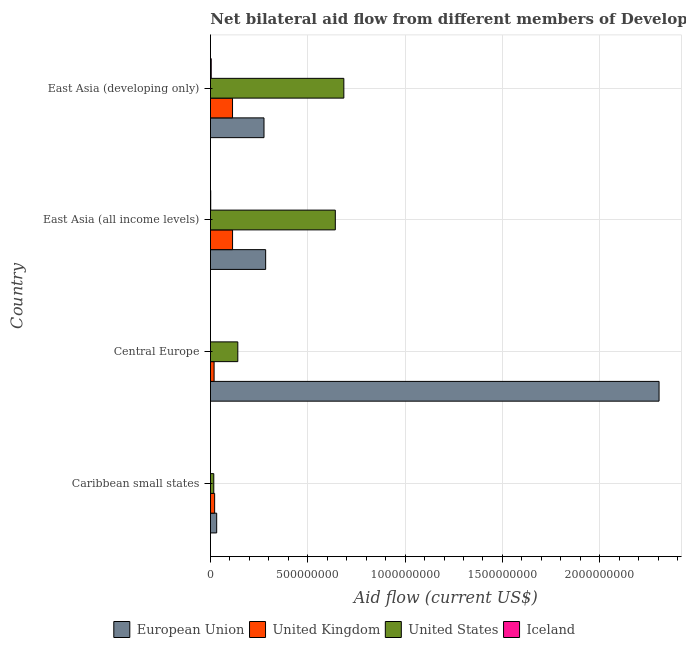How many bars are there on the 3rd tick from the bottom?
Your answer should be very brief. 4. What is the label of the 4th group of bars from the top?
Ensure brevity in your answer.  Caribbean small states. What is the amount of aid given by eu in Caribbean small states?
Your response must be concise. 3.19e+07. Across all countries, what is the maximum amount of aid given by iceland?
Offer a terse response. 3.94e+06. Across all countries, what is the minimum amount of aid given by uk?
Make the answer very short. 1.86e+07. In which country was the amount of aid given by uk maximum?
Keep it short and to the point. East Asia (all income levels). In which country was the amount of aid given by iceland minimum?
Give a very brief answer. Caribbean small states. What is the total amount of aid given by eu in the graph?
Ensure brevity in your answer.  2.90e+09. What is the difference between the amount of aid given by us in East Asia (all income levels) and that in East Asia (developing only)?
Offer a very short reply. -4.38e+07. What is the difference between the amount of aid given by eu in East Asia (all income levels) and the amount of aid given by uk in East Asia (developing only)?
Your response must be concise. 1.70e+08. What is the average amount of aid given by iceland per country?
Offer a terse response. 1.33e+06. What is the difference between the amount of aid given by uk and amount of aid given by eu in Caribbean small states?
Your answer should be very brief. -1.05e+07. What is the ratio of the amount of aid given by iceland in Central Europe to that in East Asia (developing only)?
Make the answer very short. 0.01. Is the amount of aid given by iceland in Caribbean small states less than that in East Asia (all income levels)?
Provide a short and direct response. Yes. What is the difference between the highest and the second highest amount of aid given by iceland?
Keep it short and to the point. 2.69e+06. What is the difference between the highest and the lowest amount of aid given by iceland?
Offer a terse response. 3.88e+06. In how many countries, is the amount of aid given by eu greater than the average amount of aid given by eu taken over all countries?
Provide a succinct answer. 1. What does the 4th bar from the bottom in Central Europe represents?
Provide a succinct answer. Iceland. How many countries are there in the graph?
Offer a very short reply. 4. What is the difference between two consecutive major ticks on the X-axis?
Offer a very short reply. 5.00e+08. Does the graph contain any zero values?
Provide a succinct answer. No. Where does the legend appear in the graph?
Provide a succinct answer. Bottom center. What is the title of the graph?
Provide a succinct answer. Net bilateral aid flow from different members of Development Assistance Committee in the year 2003. Does "Gender equality" appear as one of the legend labels in the graph?
Offer a terse response. No. What is the label or title of the Y-axis?
Offer a terse response. Country. What is the Aid flow (current US$) in European Union in Caribbean small states?
Keep it short and to the point. 3.19e+07. What is the Aid flow (current US$) in United Kingdom in Caribbean small states?
Provide a succinct answer. 2.14e+07. What is the Aid flow (current US$) in United States in Caribbean small states?
Your answer should be compact. 1.70e+07. What is the Aid flow (current US$) of Iceland in Caribbean small states?
Your answer should be very brief. 6.00e+04. What is the Aid flow (current US$) in European Union in Central Europe?
Your response must be concise. 2.30e+09. What is the Aid flow (current US$) in United Kingdom in Central Europe?
Provide a short and direct response. 1.86e+07. What is the Aid flow (current US$) in United States in Central Europe?
Offer a terse response. 1.40e+08. What is the Aid flow (current US$) of Iceland in Central Europe?
Give a very brief answer. 6.00e+04. What is the Aid flow (current US$) of European Union in East Asia (all income levels)?
Provide a succinct answer. 2.84e+08. What is the Aid flow (current US$) in United Kingdom in East Asia (all income levels)?
Your response must be concise. 1.13e+08. What is the Aid flow (current US$) in United States in East Asia (all income levels)?
Ensure brevity in your answer.  6.41e+08. What is the Aid flow (current US$) in Iceland in East Asia (all income levels)?
Your answer should be very brief. 1.25e+06. What is the Aid flow (current US$) in European Union in East Asia (developing only)?
Ensure brevity in your answer.  2.75e+08. What is the Aid flow (current US$) in United Kingdom in East Asia (developing only)?
Offer a terse response. 1.13e+08. What is the Aid flow (current US$) in United States in East Asia (developing only)?
Offer a terse response. 6.85e+08. What is the Aid flow (current US$) of Iceland in East Asia (developing only)?
Make the answer very short. 3.94e+06. Across all countries, what is the maximum Aid flow (current US$) of European Union?
Make the answer very short. 2.30e+09. Across all countries, what is the maximum Aid flow (current US$) in United Kingdom?
Your answer should be compact. 1.13e+08. Across all countries, what is the maximum Aid flow (current US$) of United States?
Provide a short and direct response. 6.85e+08. Across all countries, what is the maximum Aid flow (current US$) in Iceland?
Give a very brief answer. 3.94e+06. Across all countries, what is the minimum Aid flow (current US$) in European Union?
Make the answer very short. 3.19e+07. Across all countries, what is the minimum Aid flow (current US$) of United Kingdom?
Your answer should be compact. 1.86e+07. Across all countries, what is the minimum Aid flow (current US$) of United States?
Provide a short and direct response. 1.70e+07. Across all countries, what is the minimum Aid flow (current US$) of Iceland?
Offer a terse response. 6.00e+04. What is the total Aid flow (current US$) of European Union in the graph?
Provide a short and direct response. 2.90e+09. What is the total Aid flow (current US$) in United Kingdom in the graph?
Make the answer very short. 2.67e+08. What is the total Aid flow (current US$) of United States in the graph?
Give a very brief answer. 1.48e+09. What is the total Aid flow (current US$) of Iceland in the graph?
Your response must be concise. 5.31e+06. What is the difference between the Aid flow (current US$) in European Union in Caribbean small states and that in Central Europe?
Your answer should be compact. -2.27e+09. What is the difference between the Aid flow (current US$) of United Kingdom in Caribbean small states and that in Central Europe?
Keep it short and to the point. 2.83e+06. What is the difference between the Aid flow (current US$) in United States in Caribbean small states and that in Central Europe?
Ensure brevity in your answer.  -1.24e+08. What is the difference between the Aid flow (current US$) in European Union in Caribbean small states and that in East Asia (all income levels)?
Your response must be concise. -2.52e+08. What is the difference between the Aid flow (current US$) in United Kingdom in Caribbean small states and that in East Asia (all income levels)?
Provide a short and direct response. -9.20e+07. What is the difference between the Aid flow (current US$) in United States in Caribbean small states and that in East Asia (all income levels)?
Your response must be concise. -6.24e+08. What is the difference between the Aid flow (current US$) in Iceland in Caribbean small states and that in East Asia (all income levels)?
Your answer should be compact. -1.19e+06. What is the difference between the Aid flow (current US$) in European Union in Caribbean small states and that in East Asia (developing only)?
Provide a succinct answer. -2.43e+08. What is the difference between the Aid flow (current US$) of United Kingdom in Caribbean small states and that in East Asia (developing only)?
Your answer should be very brief. -9.19e+07. What is the difference between the Aid flow (current US$) in United States in Caribbean small states and that in East Asia (developing only)?
Provide a succinct answer. -6.68e+08. What is the difference between the Aid flow (current US$) of Iceland in Caribbean small states and that in East Asia (developing only)?
Offer a terse response. -3.88e+06. What is the difference between the Aid flow (current US$) in European Union in Central Europe and that in East Asia (all income levels)?
Provide a succinct answer. 2.02e+09. What is the difference between the Aid flow (current US$) of United Kingdom in Central Europe and that in East Asia (all income levels)?
Your answer should be compact. -9.49e+07. What is the difference between the Aid flow (current US$) of United States in Central Europe and that in East Asia (all income levels)?
Offer a terse response. -5.01e+08. What is the difference between the Aid flow (current US$) of Iceland in Central Europe and that in East Asia (all income levels)?
Offer a terse response. -1.19e+06. What is the difference between the Aid flow (current US$) of European Union in Central Europe and that in East Asia (developing only)?
Offer a very short reply. 2.03e+09. What is the difference between the Aid flow (current US$) of United Kingdom in Central Europe and that in East Asia (developing only)?
Offer a terse response. -9.47e+07. What is the difference between the Aid flow (current US$) in United States in Central Europe and that in East Asia (developing only)?
Offer a very short reply. -5.45e+08. What is the difference between the Aid flow (current US$) of Iceland in Central Europe and that in East Asia (developing only)?
Give a very brief answer. -3.88e+06. What is the difference between the Aid flow (current US$) in European Union in East Asia (all income levels) and that in East Asia (developing only)?
Make the answer very short. 8.50e+06. What is the difference between the Aid flow (current US$) of United Kingdom in East Asia (all income levels) and that in East Asia (developing only)?
Give a very brief answer. 1.50e+05. What is the difference between the Aid flow (current US$) in United States in East Asia (all income levels) and that in East Asia (developing only)?
Your response must be concise. -4.38e+07. What is the difference between the Aid flow (current US$) in Iceland in East Asia (all income levels) and that in East Asia (developing only)?
Provide a succinct answer. -2.69e+06. What is the difference between the Aid flow (current US$) in European Union in Caribbean small states and the Aid flow (current US$) in United Kingdom in Central Europe?
Your answer should be very brief. 1.33e+07. What is the difference between the Aid flow (current US$) in European Union in Caribbean small states and the Aid flow (current US$) in United States in Central Europe?
Ensure brevity in your answer.  -1.09e+08. What is the difference between the Aid flow (current US$) of European Union in Caribbean small states and the Aid flow (current US$) of Iceland in Central Europe?
Offer a very short reply. 3.19e+07. What is the difference between the Aid flow (current US$) in United Kingdom in Caribbean small states and the Aid flow (current US$) in United States in Central Europe?
Give a very brief answer. -1.19e+08. What is the difference between the Aid flow (current US$) in United Kingdom in Caribbean small states and the Aid flow (current US$) in Iceland in Central Europe?
Your answer should be compact. 2.14e+07. What is the difference between the Aid flow (current US$) in United States in Caribbean small states and the Aid flow (current US$) in Iceland in Central Europe?
Offer a terse response. 1.69e+07. What is the difference between the Aid flow (current US$) of European Union in Caribbean small states and the Aid flow (current US$) of United Kingdom in East Asia (all income levels)?
Provide a short and direct response. -8.16e+07. What is the difference between the Aid flow (current US$) in European Union in Caribbean small states and the Aid flow (current US$) in United States in East Asia (all income levels)?
Provide a succinct answer. -6.10e+08. What is the difference between the Aid flow (current US$) of European Union in Caribbean small states and the Aid flow (current US$) of Iceland in East Asia (all income levels)?
Provide a succinct answer. 3.07e+07. What is the difference between the Aid flow (current US$) of United Kingdom in Caribbean small states and the Aid flow (current US$) of United States in East Asia (all income levels)?
Ensure brevity in your answer.  -6.20e+08. What is the difference between the Aid flow (current US$) in United Kingdom in Caribbean small states and the Aid flow (current US$) in Iceland in East Asia (all income levels)?
Keep it short and to the point. 2.02e+07. What is the difference between the Aid flow (current US$) in United States in Caribbean small states and the Aid flow (current US$) in Iceland in East Asia (all income levels)?
Your response must be concise. 1.57e+07. What is the difference between the Aid flow (current US$) of European Union in Caribbean small states and the Aid flow (current US$) of United Kingdom in East Asia (developing only)?
Provide a succinct answer. -8.14e+07. What is the difference between the Aid flow (current US$) in European Union in Caribbean small states and the Aid flow (current US$) in United States in East Asia (developing only)?
Provide a short and direct response. -6.53e+08. What is the difference between the Aid flow (current US$) of European Union in Caribbean small states and the Aid flow (current US$) of Iceland in East Asia (developing only)?
Offer a very short reply. 2.80e+07. What is the difference between the Aid flow (current US$) in United Kingdom in Caribbean small states and the Aid flow (current US$) in United States in East Asia (developing only)?
Your answer should be compact. -6.64e+08. What is the difference between the Aid flow (current US$) in United Kingdom in Caribbean small states and the Aid flow (current US$) in Iceland in East Asia (developing only)?
Offer a very short reply. 1.75e+07. What is the difference between the Aid flow (current US$) of United States in Caribbean small states and the Aid flow (current US$) of Iceland in East Asia (developing only)?
Ensure brevity in your answer.  1.30e+07. What is the difference between the Aid flow (current US$) in European Union in Central Europe and the Aid flow (current US$) in United Kingdom in East Asia (all income levels)?
Your answer should be very brief. 2.19e+09. What is the difference between the Aid flow (current US$) in European Union in Central Europe and the Aid flow (current US$) in United States in East Asia (all income levels)?
Keep it short and to the point. 1.66e+09. What is the difference between the Aid flow (current US$) of European Union in Central Europe and the Aid flow (current US$) of Iceland in East Asia (all income levels)?
Make the answer very short. 2.30e+09. What is the difference between the Aid flow (current US$) in United Kingdom in Central Europe and the Aid flow (current US$) in United States in East Asia (all income levels)?
Your answer should be compact. -6.23e+08. What is the difference between the Aid flow (current US$) of United Kingdom in Central Europe and the Aid flow (current US$) of Iceland in East Asia (all income levels)?
Keep it short and to the point. 1.74e+07. What is the difference between the Aid flow (current US$) of United States in Central Europe and the Aid flow (current US$) of Iceland in East Asia (all income levels)?
Your answer should be compact. 1.39e+08. What is the difference between the Aid flow (current US$) in European Union in Central Europe and the Aid flow (current US$) in United Kingdom in East Asia (developing only)?
Offer a terse response. 2.19e+09. What is the difference between the Aid flow (current US$) in European Union in Central Europe and the Aid flow (current US$) in United States in East Asia (developing only)?
Make the answer very short. 1.62e+09. What is the difference between the Aid flow (current US$) of European Union in Central Europe and the Aid flow (current US$) of Iceland in East Asia (developing only)?
Your answer should be compact. 2.30e+09. What is the difference between the Aid flow (current US$) in United Kingdom in Central Europe and the Aid flow (current US$) in United States in East Asia (developing only)?
Your answer should be compact. -6.67e+08. What is the difference between the Aid flow (current US$) of United Kingdom in Central Europe and the Aid flow (current US$) of Iceland in East Asia (developing only)?
Your response must be concise. 1.47e+07. What is the difference between the Aid flow (current US$) in United States in Central Europe and the Aid flow (current US$) in Iceland in East Asia (developing only)?
Provide a short and direct response. 1.37e+08. What is the difference between the Aid flow (current US$) in European Union in East Asia (all income levels) and the Aid flow (current US$) in United Kingdom in East Asia (developing only)?
Your answer should be very brief. 1.70e+08. What is the difference between the Aid flow (current US$) of European Union in East Asia (all income levels) and the Aid flow (current US$) of United States in East Asia (developing only)?
Offer a terse response. -4.02e+08. What is the difference between the Aid flow (current US$) in European Union in East Asia (all income levels) and the Aid flow (current US$) in Iceland in East Asia (developing only)?
Keep it short and to the point. 2.80e+08. What is the difference between the Aid flow (current US$) of United Kingdom in East Asia (all income levels) and the Aid flow (current US$) of United States in East Asia (developing only)?
Give a very brief answer. -5.72e+08. What is the difference between the Aid flow (current US$) in United Kingdom in East Asia (all income levels) and the Aid flow (current US$) in Iceland in East Asia (developing only)?
Your answer should be compact. 1.10e+08. What is the difference between the Aid flow (current US$) in United States in East Asia (all income levels) and the Aid flow (current US$) in Iceland in East Asia (developing only)?
Offer a very short reply. 6.38e+08. What is the average Aid flow (current US$) in European Union per country?
Make the answer very short. 7.24e+08. What is the average Aid flow (current US$) of United Kingdom per country?
Provide a short and direct response. 6.67e+07. What is the average Aid flow (current US$) in United States per country?
Your response must be concise. 3.71e+08. What is the average Aid flow (current US$) in Iceland per country?
Your response must be concise. 1.33e+06. What is the difference between the Aid flow (current US$) of European Union and Aid flow (current US$) of United Kingdom in Caribbean small states?
Offer a terse response. 1.05e+07. What is the difference between the Aid flow (current US$) in European Union and Aid flow (current US$) in United States in Caribbean small states?
Ensure brevity in your answer.  1.49e+07. What is the difference between the Aid flow (current US$) of European Union and Aid flow (current US$) of Iceland in Caribbean small states?
Keep it short and to the point. 3.19e+07. What is the difference between the Aid flow (current US$) of United Kingdom and Aid flow (current US$) of United States in Caribbean small states?
Offer a terse response. 4.47e+06. What is the difference between the Aid flow (current US$) of United Kingdom and Aid flow (current US$) of Iceland in Caribbean small states?
Your answer should be compact. 2.14e+07. What is the difference between the Aid flow (current US$) in United States and Aid flow (current US$) in Iceland in Caribbean small states?
Offer a very short reply. 1.69e+07. What is the difference between the Aid flow (current US$) in European Union and Aid flow (current US$) in United Kingdom in Central Europe?
Make the answer very short. 2.29e+09. What is the difference between the Aid flow (current US$) in European Union and Aid flow (current US$) in United States in Central Europe?
Offer a very short reply. 2.16e+09. What is the difference between the Aid flow (current US$) of European Union and Aid flow (current US$) of Iceland in Central Europe?
Your answer should be compact. 2.30e+09. What is the difference between the Aid flow (current US$) in United Kingdom and Aid flow (current US$) in United States in Central Europe?
Give a very brief answer. -1.22e+08. What is the difference between the Aid flow (current US$) of United Kingdom and Aid flow (current US$) of Iceland in Central Europe?
Your answer should be very brief. 1.86e+07. What is the difference between the Aid flow (current US$) in United States and Aid flow (current US$) in Iceland in Central Europe?
Offer a very short reply. 1.40e+08. What is the difference between the Aid flow (current US$) in European Union and Aid flow (current US$) in United Kingdom in East Asia (all income levels)?
Offer a very short reply. 1.70e+08. What is the difference between the Aid flow (current US$) in European Union and Aid flow (current US$) in United States in East Asia (all income levels)?
Your answer should be compact. -3.58e+08. What is the difference between the Aid flow (current US$) of European Union and Aid flow (current US$) of Iceland in East Asia (all income levels)?
Ensure brevity in your answer.  2.82e+08. What is the difference between the Aid flow (current US$) in United Kingdom and Aid flow (current US$) in United States in East Asia (all income levels)?
Ensure brevity in your answer.  -5.28e+08. What is the difference between the Aid flow (current US$) in United Kingdom and Aid flow (current US$) in Iceland in East Asia (all income levels)?
Your answer should be very brief. 1.12e+08. What is the difference between the Aid flow (current US$) of United States and Aid flow (current US$) of Iceland in East Asia (all income levels)?
Your answer should be very brief. 6.40e+08. What is the difference between the Aid flow (current US$) of European Union and Aid flow (current US$) of United Kingdom in East Asia (developing only)?
Provide a short and direct response. 1.62e+08. What is the difference between the Aid flow (current US$) in European Union and Aid flow (current US$) in United States in East Asia (developing only)?
Your answer should be very brief. -4.10e+08. What is the difference between the Aid flow (current US$) in European Union and Aid flow (current US$) in Iceland in East Asia (developing only)?
Your answer should be compact. 2.71e+08. What is the difference between the Aid flow (current US$) of United Kingdom and Aid flow (current US$) of United States in East Asia (developing only)?
Provide a short and direct response. -5.72e+08. What is the difference between the Aid flow (current US$) in United Kingdom and Aid flow (current US$) in Iceland in East Asia (developing only)?
Provide a short and direct response. 1.09e+08. What is the difference between the Aid flow (current US$) in United States and Aid flow (current US$) in Iceland in East Asia (developing only)?
Offer a very short reply. 6.81e+08. What is the ratio of the Aid flow (current US$) of European Union in Caribbean small states to that in Central Europe?
Give a very brief answer. 0.01. What is the ratio of the Aid flow (current US$) in United Kingdom in Caribbean small states to that in Central Europe?
Provide a short and direct response. 1.15. What is the ratio of the Aid flow (current US$) in United States in Caribbean small states to that in Central Europe?
Make the answer very short. 0.12. What is the ratio of the Aid flow (current US$) in Iceland in Caribbean small states to that in Central Europe?
Ensure brevity in your answer.  1. What is the ratio of the Aid flow (current US$) of European Union in Caribbean small states to that in East Asia (all income levels)?
Ensure brevity in your answer.  0.11. What is the ratio of the Aid flow (current US$) in United Kingdom in Caribbean small states to that in East Asia (all income levels)?
Give a very brief answer. 0.19. What is the ratio of the Aid flow (current US$) of United States in Caribbean small states to that in East Asia (all income levels)?
Ensure brevity in your answer.  0.03. What is the ratio of the Aid flow (current US$) of Iceland in Caribbean small states to that in East Asia (all income levels)?
Keep it short and to the point. 0.05. What is the ratio of the Aid flow (current US$) in European Union in Caribbean small states to that in East Asia (developing only)?
Offer a terse response. 0.12. What is the ratio of the Aid flow (current US$) of United Kingdom in Caribbean small states to that in East Asia (developing only)?
Offer a terse response. 0.19. What is the ratio of the Aid flow (current US$) of United States in Caribbean small states to that in East Asia (developing only)?
Offer a very short reply. 0.02. What is the ratio of the Aid flow (current US$) of Iceland in Caribbean small states to that in East Asia (developing only)?
Your answer should be compact. 0.02. What is the ratio of the Aid flow (current US$) of European Union in Central Europe to that in East Asia (all income levels)?
Your response must be concise. 8.13. What is the ratio of the Aid flow (current US$) of United Kingdom in Central Europe to that in East Asia (all income levels)?
Make the answer very short. 0.16. What is the ratio of the Aid flow (current US$) in United States in Central Europe to that in East Asia (all income levels)?
Offer a terse response. 0.22. What is the ratio of the Aid flow (current US$) in Iceland in Central Europe to that in East Asia (all income levels)?
Make the answer very short. 0.05. What is the ratio of the Aid flow (current US$) in European Union in Central Europe to that in East Asia (developing only)?
Give a very brief answer. 8.38. What is the ratio of the Aid flow (current US$) of United Kingdom in Central Europe to that in East Asia (developing only)?
Offer a very short reply. 0.16. What is the ratio of the Aid flow (current US$) in United States in Central Europe to that in East Asia (developing only)?
Give a very brief answer. 0.2. What is the ratio of the Aid flow (current US$) of Iceland in Central Europe to that in East Asia (developing only)?
Offer a very short reply. 0.02. What is the ratio of the Aid flow (current US$) in European Union in East Asia (all income levels) to that in East Asia (developing only)?
Make the answer very short. 1.03. What is the ratio of the Aid flow (current US$) in United States in East Asia (all income levels) to that in East Asia (developing only)?
Your answer should be compact. 0.94. What is the ratio of the Aid flow (current US$) of Iceland in East Asia (all income levels) to that in East Asia (developing only)?
Give a very brief answer. 0.32. What is the difference between the highest and the second highest Aid flow (current US$) of European Union?
Keep it short and to the point. 2.02e+09. What is the difference between the highest and the second highest Aid flow (current US$) in United States?
Make the answer very short. 4.38e+07. What is the difference between the highest and the second highest Aid flow (current US$) of Iceland?
Provide a short and direct response. 2.69e+06. What is the difference between the highest and the lowest Aid flow (current US$) of European Union?
Give a very brief answer. 2.27e+09. What is the difference between the highest and the lowest Aid flow (current US$) in United Kingdom?
Keep it short and to the point. 9.49e+07. What is the difference between the highest and the lowest Aid flow (current US$) in United States?
Your response must be concise. 6.68e+08. What is the difference between the highest and the lowest Aid flow (current US$) in Iceland?
Your answer should be very brief. 3.88e+06. 